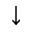<formula> <loc_0><loc_0><loc_500><loc_500>\downarrow</formula> 